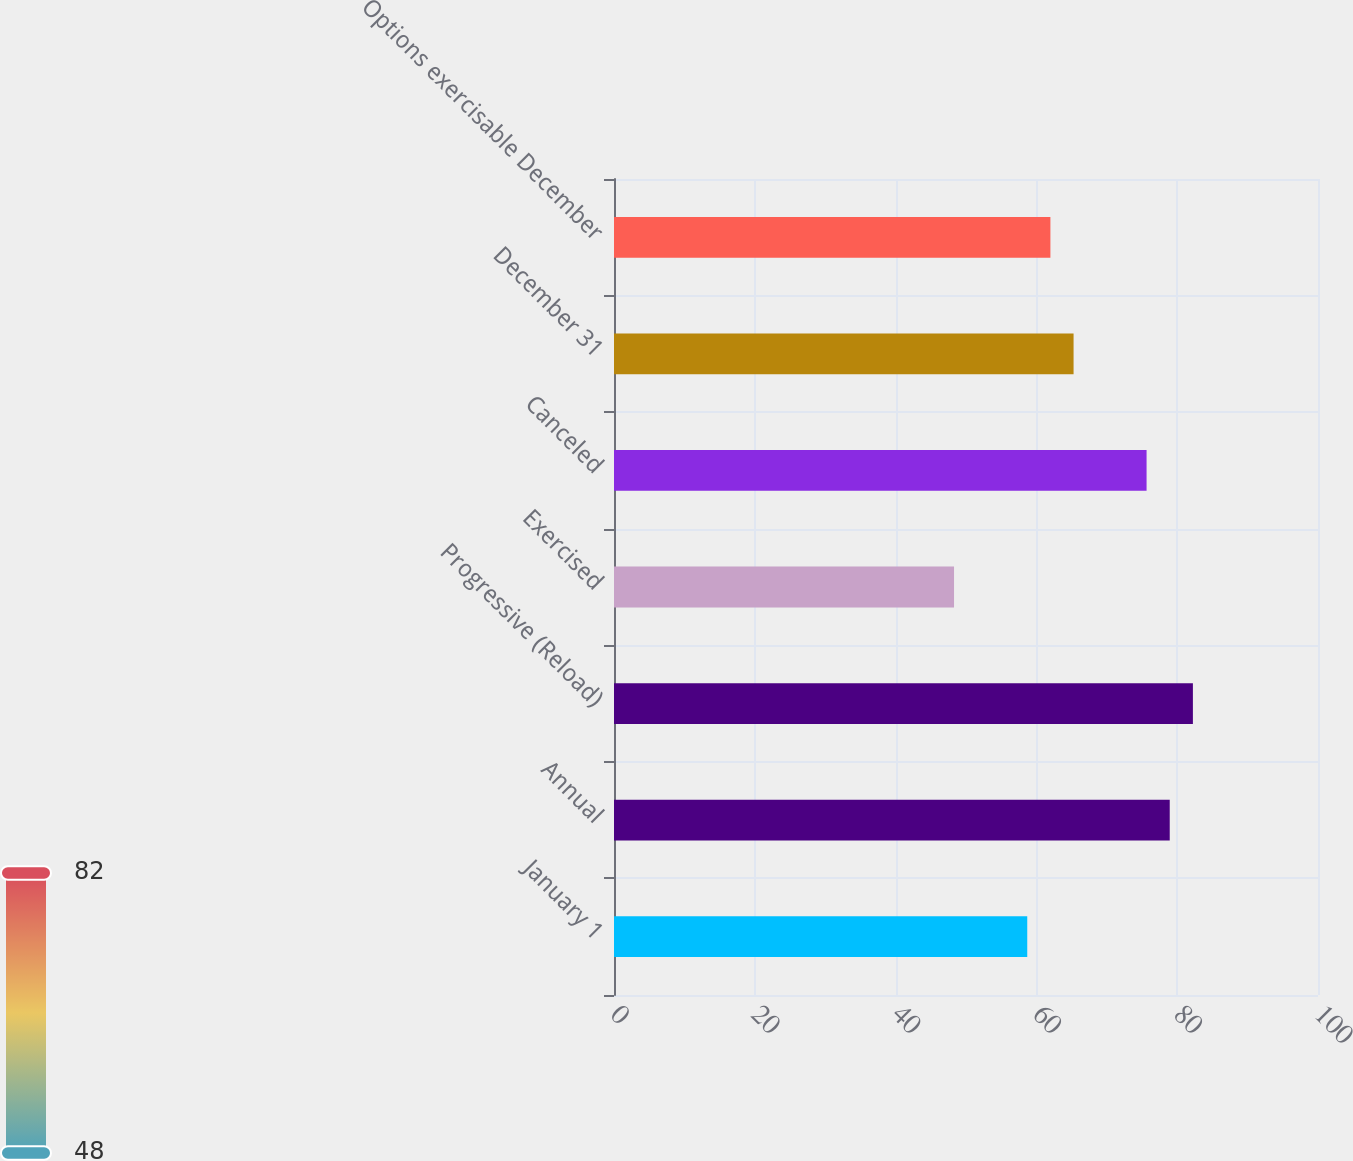<chart> <loc_0><loc_0><loc_500><loc_500><bar_chart><fcel>January 1<fcel>Annual<fcel>Progressive (Reload)<fcel>Exercised<fcel>Canceled<fcel>December 31<fcel>Options exercisable December<nl><fcel>58.7<fcel>78.94<fcel>82.23<fcel>48.3<fcel>75.65<fcel>65.28<fcel>61.99<nl></chart> 